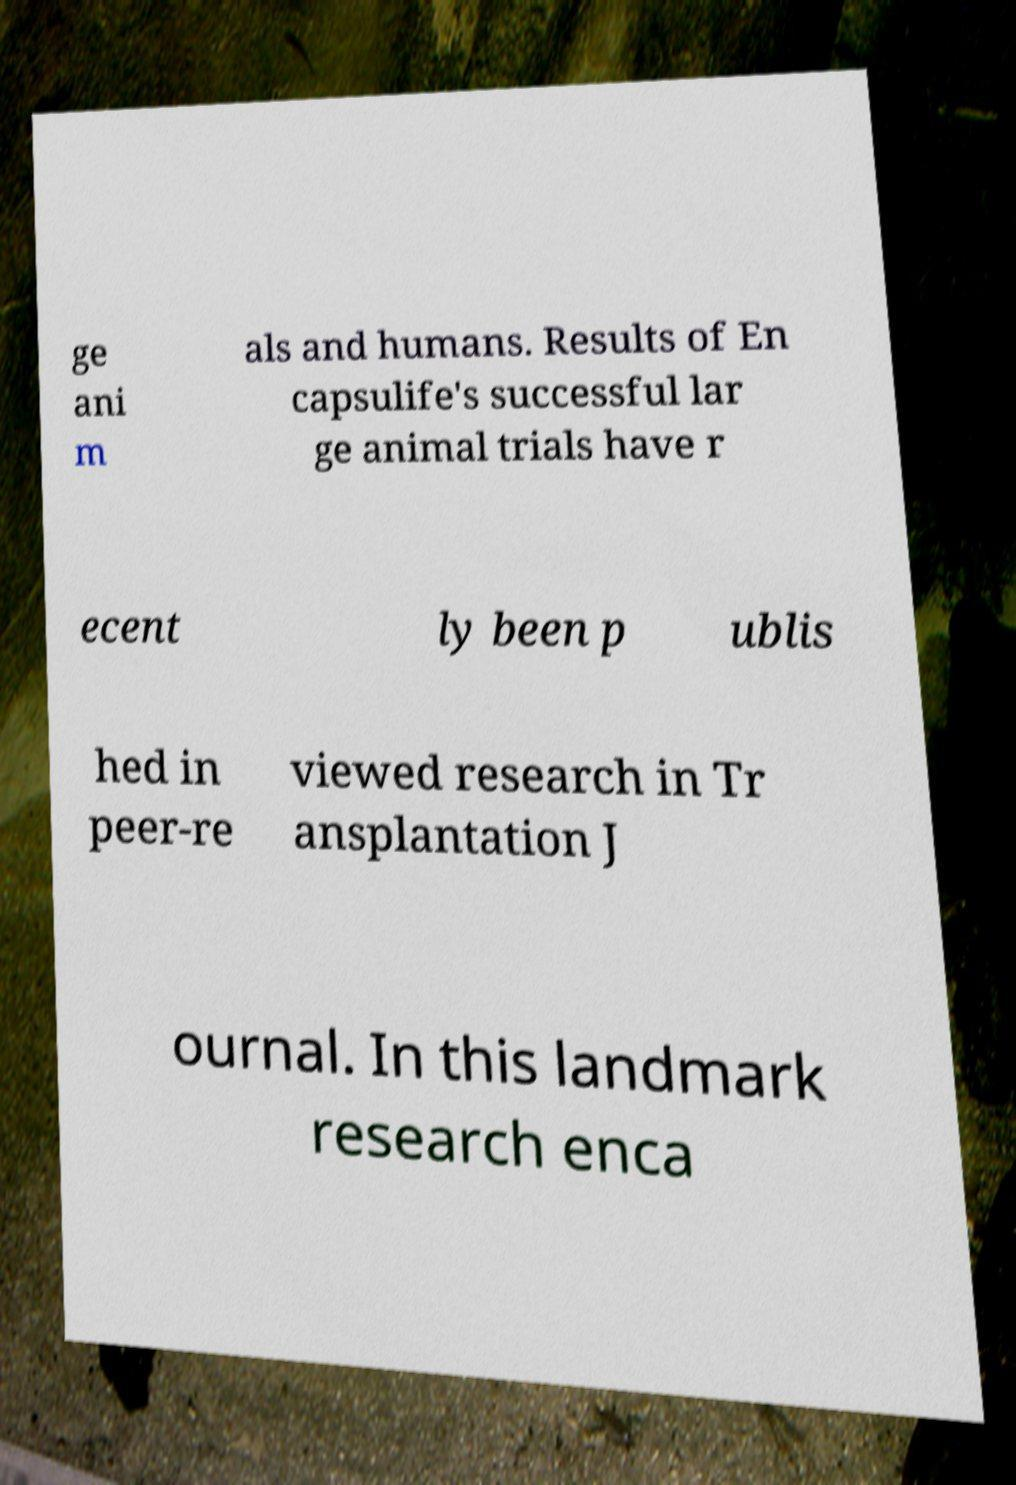For documentation purposes, I need the text within this image transcribed. Could you provide that? ge ani m als and humans. Results of En capsulife's successful lar ge animal trials have r ecent ly been p ublis hed in peer-re viewed research in Tr ansplantation J ournal. In this landmark research enca 